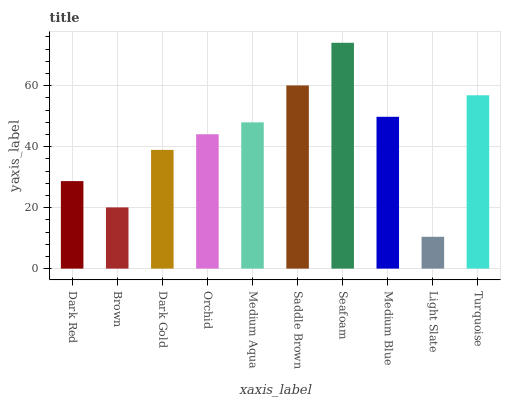Is Light Slate the minimum?
Answer yes or no. Yes. Is Seafoam the maximum?
Answer yes or no. Yes. Is Brown the minimum?
Answer yes or no. No. Is Brown the maximum?
Answer yes or no. No. Is Dark Red greater than Brown?
Answer yes or no. Yes. Is Brown less than Dark Red?
Answer yes or no. Yes. Is Brown greater than Dark Red?
Answer yes or no. No. Is Dark Red less than Brown?
Answer yes or no. No. Is Medium Aqua the high median?
Answer yes or no. Yes. Is Orchid the low median?
Answer yes or no. Yes. Is Orchid the high median?
Answer yes or no. No. Is Light Slate the low median?
Answer yes or no. No. 